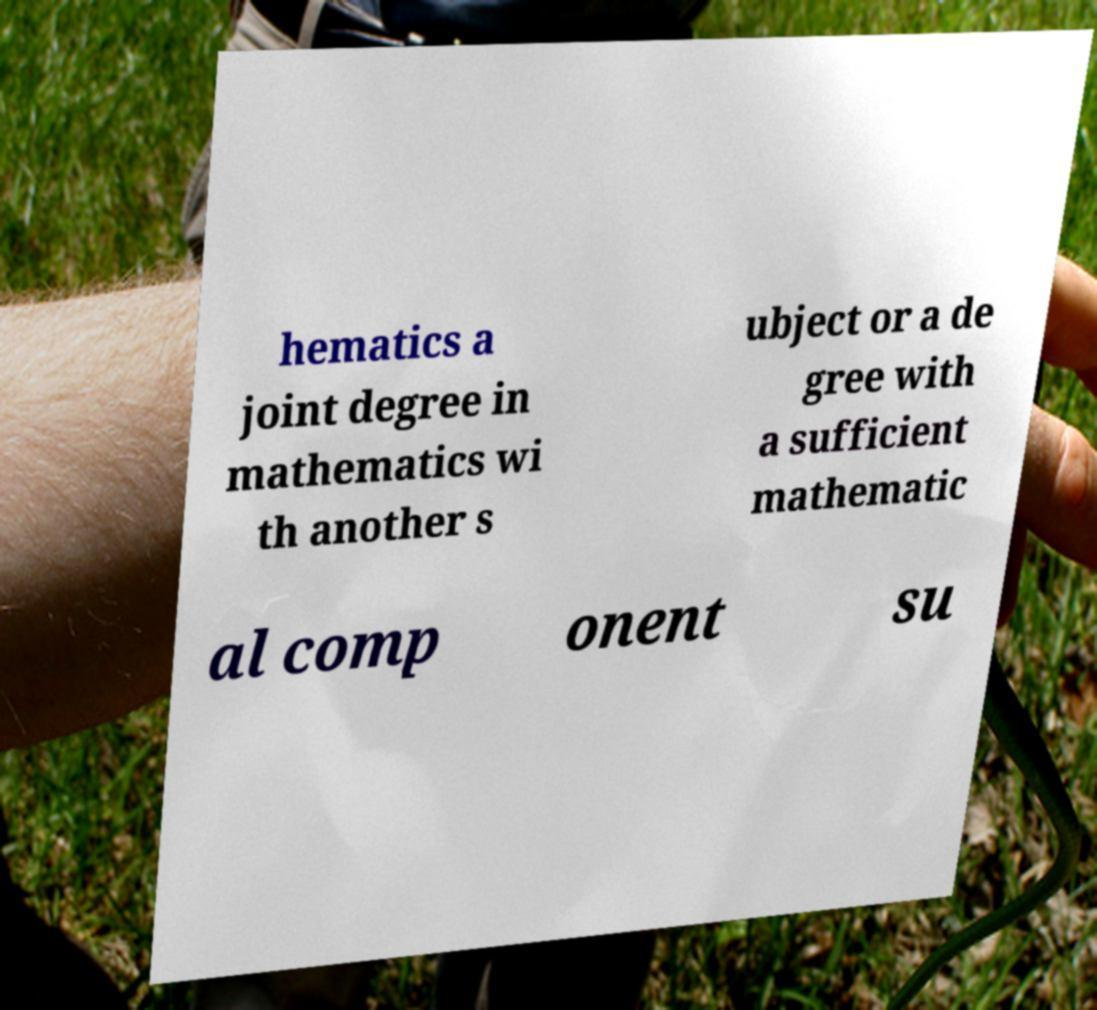For documentation purposes, I need the text within this image transcribed. Could you provide that? hematics a joint degree in mathematics wi th another s ubject or a de gree with a sufficient mathematic al comp onent su 